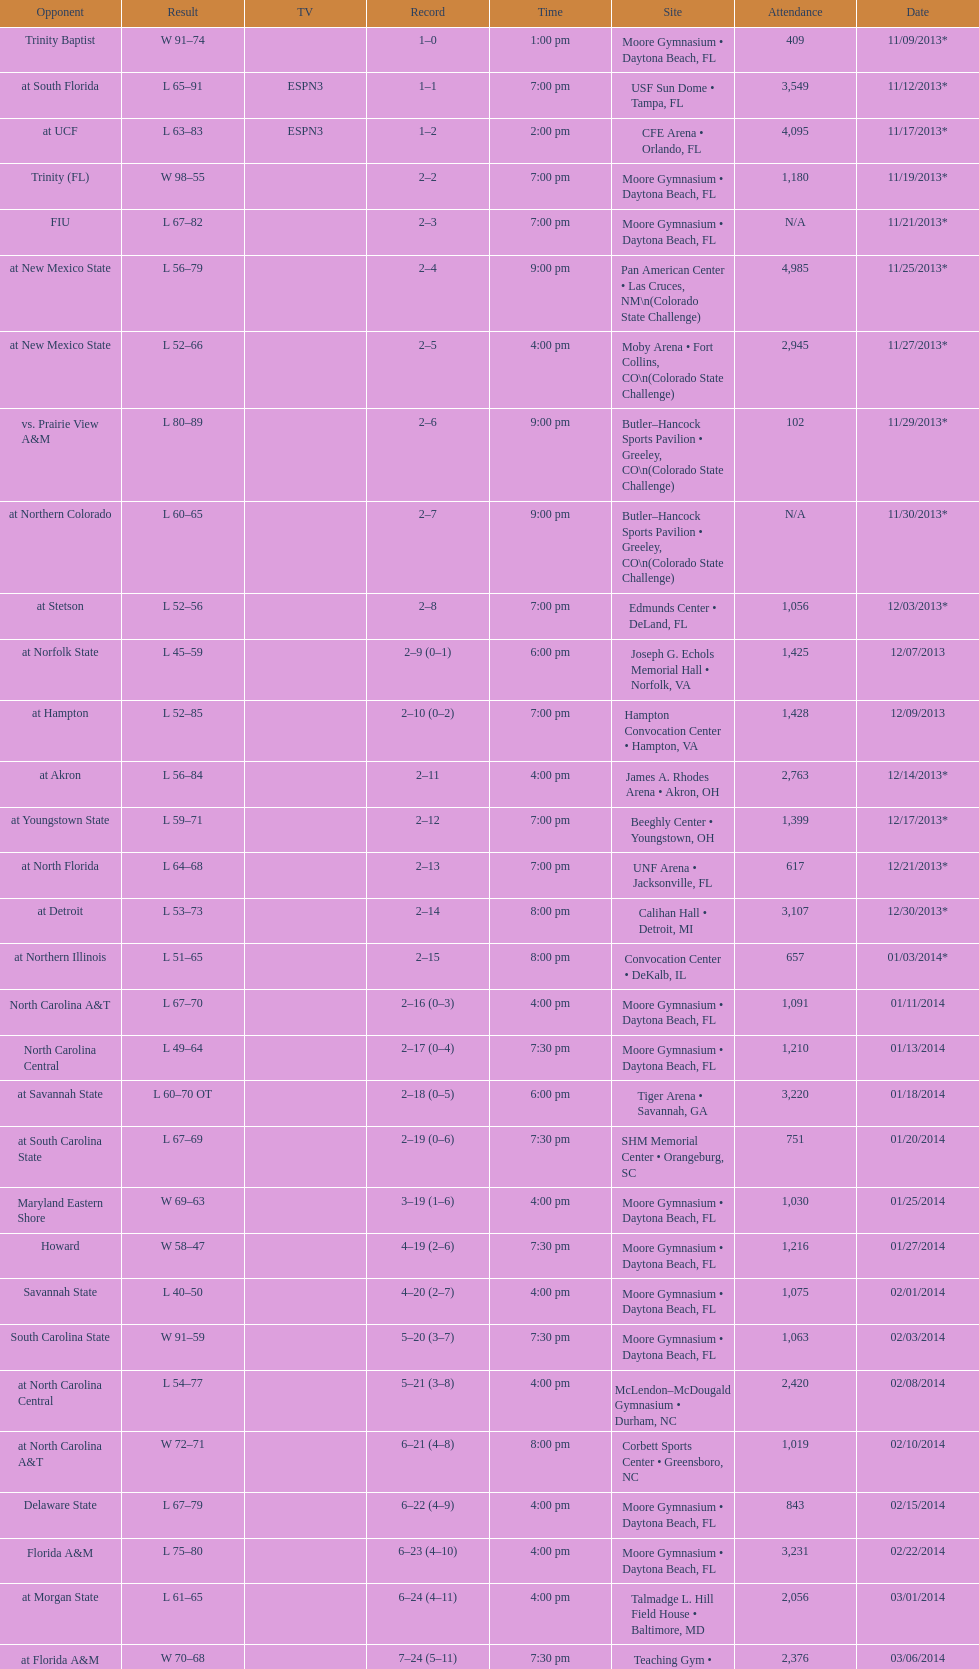Was the attendance of the game held on 11/19/2013 greater than 1,000? Yes. 